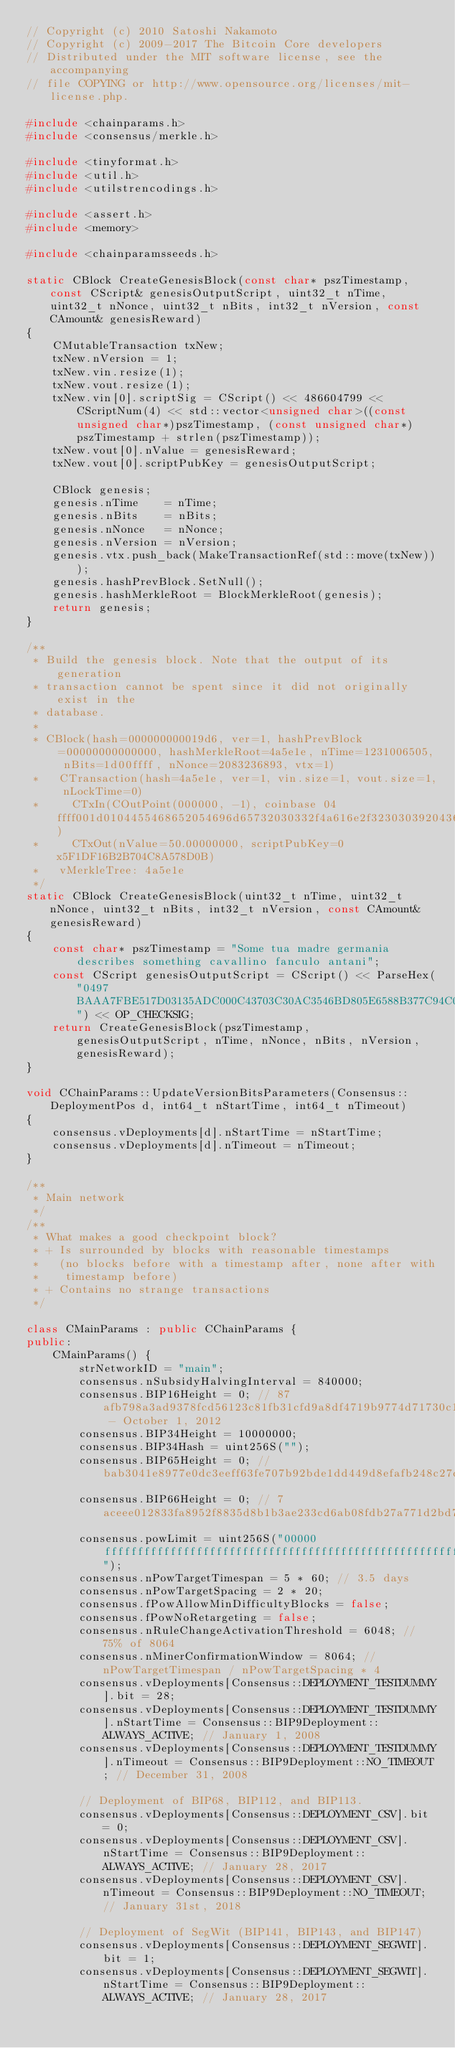<code> <loc_0><loc_0><loc_500><loc_500><_C++_>// Copyright (c) 2010 Satoshi Nakamoto
// Copyright (c) 2009-2017 The Bitcoin Core developers
// Distributed under the MIT software license, see the accompanying
// file COPYING or http://www.opensource.org/licenses/mit-license.php.

#include <chainparams.h>
#include <consensus/merkle.h>

#include <tinyformat.h>
#include <util.h>
#include <utilstrencodings.h>

#include <assert.h>
#include <memory>

#include <chainparamsseeds.h>

static CBlock CreateGenesisBlock(const char* pszTimestamp, const CScript& genesisOutputScript, uint32_t nTime, uint32_t nNonce, uint32_t nBits, int32_t nVersion, const CAmount& genesisReward)
{
    CMutableTransaction txNew;
    txNew.nVersion = 1;
    txNew.vin.resize(1);
    txNew.vout.resize(1);
    txNew.vin[0].scriptSig = CScript() << 486604799 << CScriptNum(4) << std::vector<unsigned char>((const unsigned char*)pszTimestamp, (const unsigned char*)pszTimestamp + strlen(pszTimestamp));
    txNew.vout[0].nValue = genesisReward;
    txNew.vout[0].scriptPubKey = genesisOutputScript;

    CBlock genesis;
    genesis.nTime    = nTime;
    genesis.nBits    = nBits;
    genesis.nNonce   = nNonce;
    genesis.nVersion = nVersion;
    genesis.vtx.push_back(MakeTransactionRef(std::move(txNew)));
    genesis.hashPrevBlock.SetNull();
    genesis.hashMerkleRoot = BlockMerkleRoot(genesis);
    return genesis;
}

/**
 * Build the genesis block. Note that the output of its generation
 * transaction cannot be spent since it did not originally exist in the
 * database.
 *
 * CBlock(hash=000000000019d6, ver=1, hashPrevBlock=00000000000000, hashMerkleRoot=4a5e1e, nTime=1231006505, nBits=1d00ffff, nNonce=2083236893, vtx=1)
 *   CTransaction(hash=4a5e1e, ver=1, vin.size=1, vout.size=1, nLockTime=0)
 *     CTxIn(COutPoint(000000, -1), coinbase 04ffff001d0104455468652054696d65732030332f4a616e2f32303039204368616e63656c6c6f72206f6e206272696e6b206f66207365636f6e64206261696c6f757420666f722062616e6b73)
 *     CTxOut(nValue=50.00000000, scriptPubKey=0x5F1DF16B2B704C8A578D0B)
 *   vMerkleTree: 4a5e1e
 */
static CBlock CreateGenesisBlock(uint32_t nTime, uint32_t nNonce, uint32_t nBits, int32_t nVersion, const CAmount& genesisReward)
{
    const char* pszTimestamp = "Some tua madre germania describes something cavallino fanculo antani";
    const CScript genesisOutputScript = CScript() << ParseHex("0497BAAA7FBE517D03135ADC000C43703C30AC3546BD805E6588B377C94C098237F9D6A3D5DE80AD99EE50474998D80FEC5F49979DEA0071D262904A7794057A66") << OP_CHECKSIG;
    return CreateGenesisBlock(pszTimestamp, genesisOutputScript, nTime, nNonce, nBits, nVersion, genesisReward);
}

void CChainParams::UpdateVersionBitsParameters(Consensus::DeploymentPos d, int64_t nStartTime, int64_t nTimeout)
{
    consensus.vDeployments[d].nStartTime = nStartTime;
    consensus.vDeployments[d].nTimeout = nTimeout;
}

/**
 * Main network
 */
/**
 * What makes a good checkpoint block?
 * + Is surrounded by blocks with reasonable timestamps
 *   (no blocks before with a timestamp after, none after with
 *    timestamp before)
 * + Contains no strange transactions
 */

class CMainParams : public CChainParams {
public:
    CMainParams() {
        strNetworkID = "main";
        consensus.nSubsidyHalvingInterval = 840000;
        consensus.BIP16Height = 0; // 87afb798a3ad9378fcd56123c81fb31cfd9a8df4719b9774d71730c16315a092 - October 1, 2012
        consensus.BIP34Height = 10000000;
        consensus.BIP34Hash = uint256S("");
        consensus.BIP65Height = 0; // bab3041e8977e0dc3eeff63fe707b92bde1dd449d8efafb248c27c8264cc311a
        consensus.BIP66Height = 0; // 7aceee012833fa8952f8835d8b1b3ae233cd6ab08fdb27a771d2bd7bdc491894
        consensus.powLimit = uint256S("00000fffffffffffffffffffffffffffffffffffffffffffffffffffffffffff"); 
        consensus.nPowTargetTimespan = 5 * 60; // 3.5 days
        consensus.nPowTargetSpacing = 2 * 20;
        consensus.fPowAllowMinDifficultyBlocks = false;
        consensus.fPowNoRetargeting = false;
        consensus.nRuleChangeActivationThreshold = 6048; // 75% of 8064
        consensus.nMinerConfirmationWindow = 8064; // nPowTargetTimespan / nPowTargetSpacing * 4
        consensus.vDeployments[Consensus::DEPLOYMENT_TESTDUMMY].bit = 28;
        consensus.vDeployments[Consensus::DEPLOYMENT_TESTDUMMY].nStartTime = Consensus::BIP9Deployment::ALWAYS_ACTIVE; // January 1, 2008
        consensus.vDeployments[Consensus::DEPLOYMENT_TESTDUMMY].nTimeout = Consensus::BIP9Deployment::NO_TIMEOUT; // December 31, 2008

        // Deployment of BIP68, BIP112, and BIP113.
        consensus.vDeployments[Consensus::DEPLOYMENT_CSV].bit = 0;
        consensus.vDeployments[Consensus::DEPLOYMENT_CSV].nStartTime = Consensus::BIP9Deployment::ALWAYS_ACTIVE; // January 28, 2017
        consensus.vDeployments[Consensus::DEPLOYMENT_CSV].nTimeout = Consensus::BIP9Deployment::NO_TIMEOUT; // January 31st, 2018

        // Deployment of SegWit (BIP141, BIP143, and BIP147)
        consensus.vDeployments[Consensus::DEPLOYMENT_SEGWIT].bit = 1;
        consensus.vDeployments[Consensus::DEPLOYMENT_SEGWIT].nStartTime = Consensus::BIP9Deployment::ALWAYS_ACTIVE; // January 28, 2017</code> 